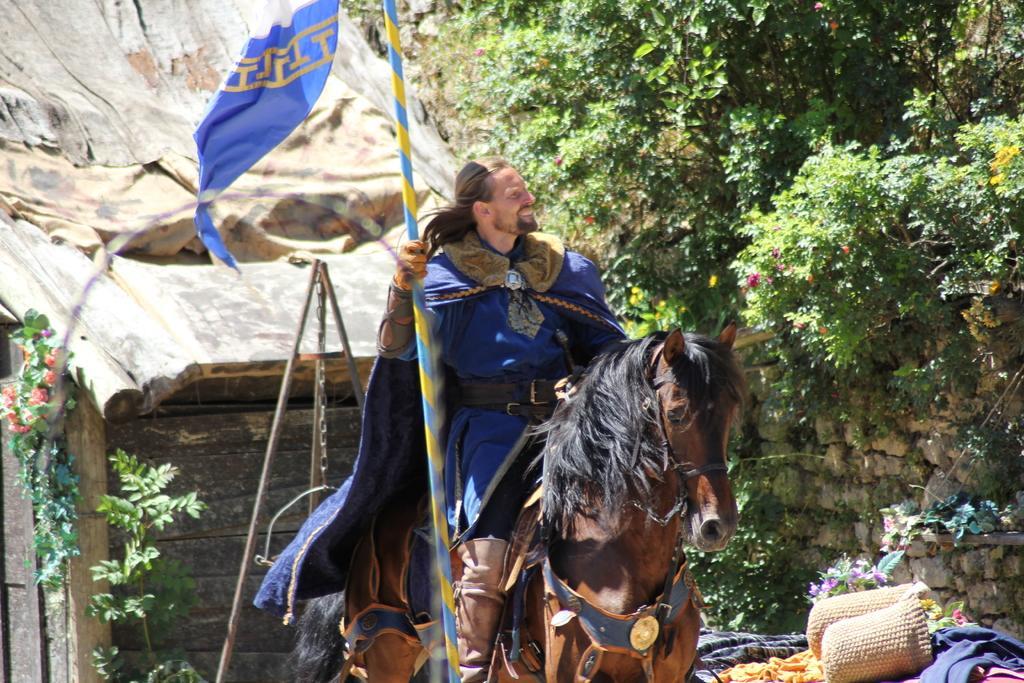How would you summarize this image in a sentence or two? In this picture we can see man wore coat smiling and holding flag pole in one hand and riding horse and in background we can see hut, trees, wall, baskets. 